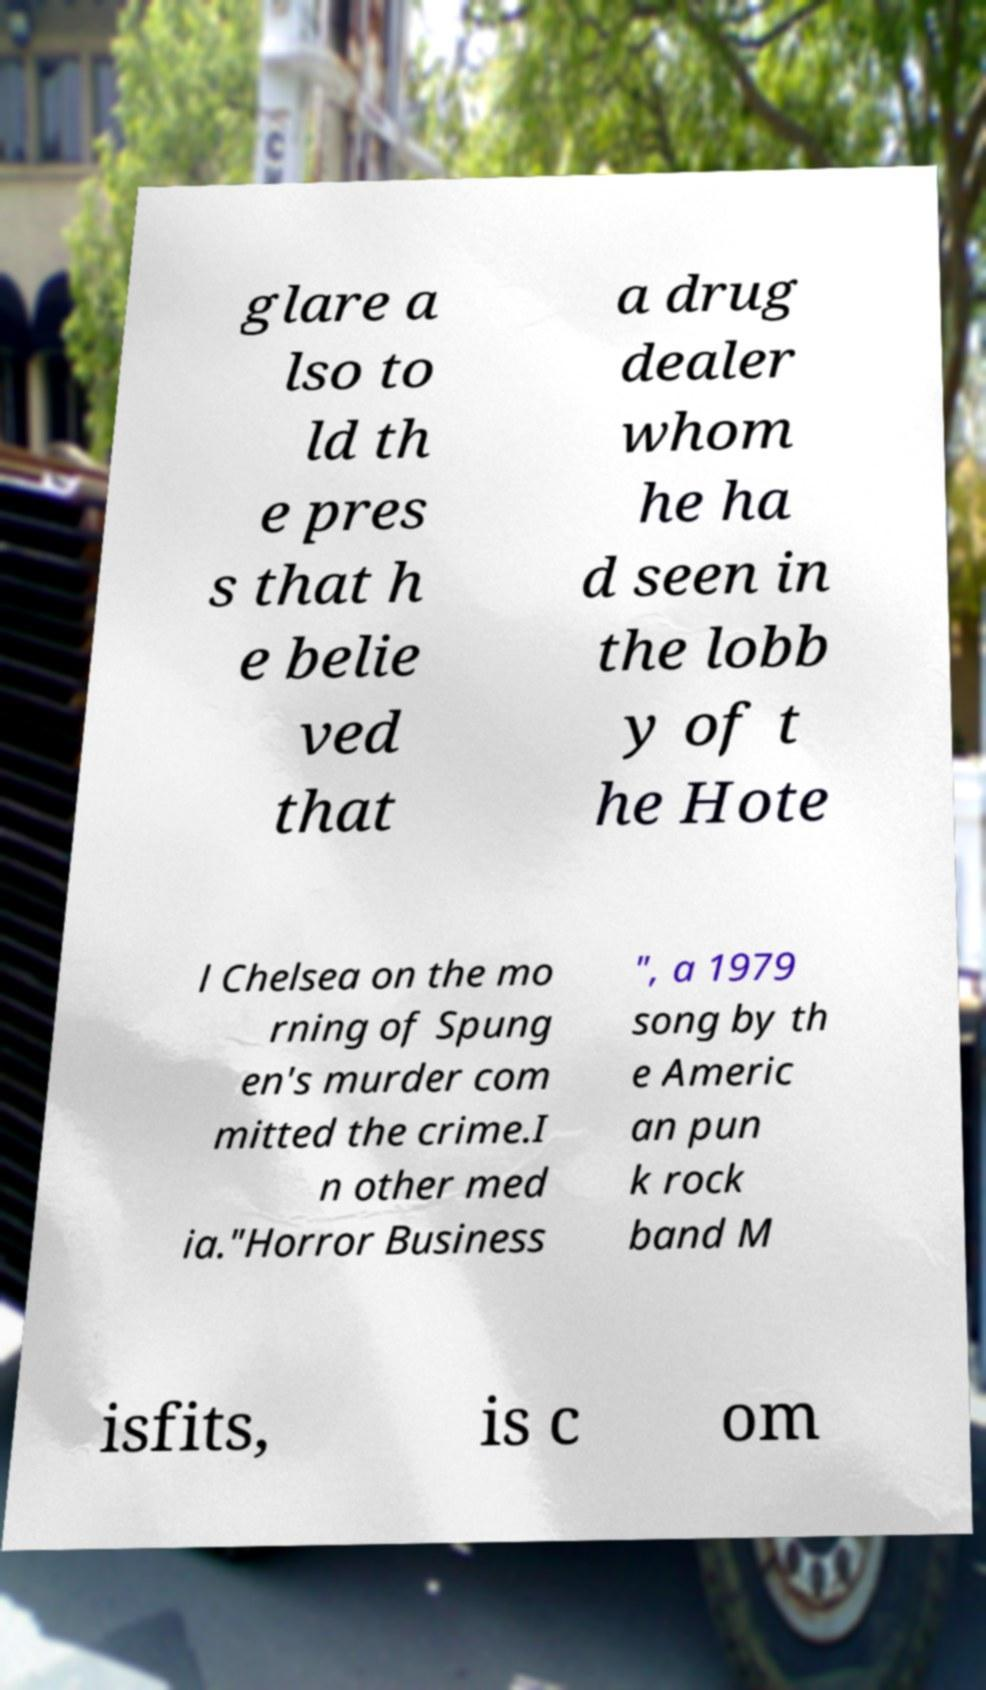Please read and relay the text visible in this image. What does it say? glare a lso to ld th e pres s that h e belie ved that a drug dealer whom he ha d seen in the lobb y of t he Hote l Chelsea on the mo rning of Spung en's murder com mitted the crime.I n other med ia."Horror Business ", a 1979 song by th e Americ an pun k rock band M isfits, is c om 